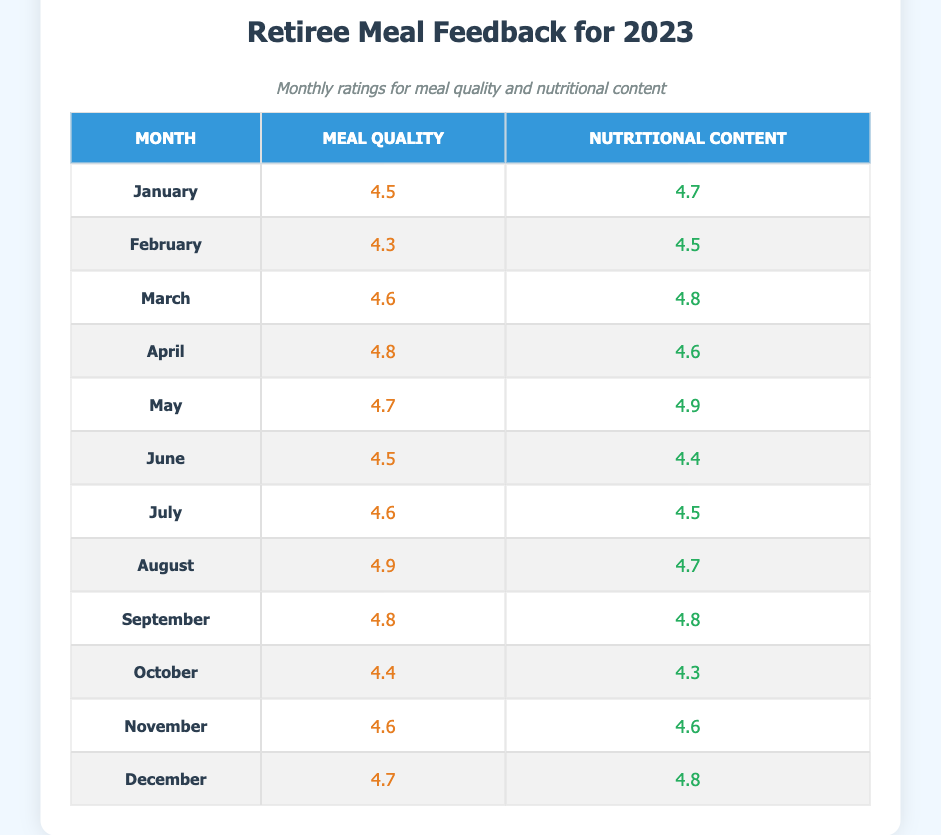What was the meal quality rating for March? The meal quality rating for March is listed directly in the table under the month of March. It shows a value of 4.6.
Answer: 4.6 Which month received the highest rating for nutritional content? The highest nutritional content rating can be found by reviewing each month's rating in the table. August has the highest rating at 4.9.
Answer: August What was the average meal quality rating for the first quarter (January, February, March)? To find the average for the first quarter, add the meal quality ratings for January (4.5), February (4.3), and March (4.6) which equals 13.4. Then divide by 3, resulting in an average of approximately 4.47.
Answer: 4.47 Is the meal quality rating for October higher or lower than the average meal quality rating for the entire year? First, we calculate the average meal quality rating for the year using the values from all months: (4.5+4.3+4.6+4.8+4.7+4.5+4.6+4.9+4.8+4.4+4.6+4.7) = 54.8 which divided by 12 gives about 4.57. October has a rating of 4.4, which is lower than 4.57.
Answer: Lower Which month saw a decrease in meal quality compared to the previous month? By examining the meal quality ratings month by month, June (4.5) is lower than May (4.7), indicating a decrease.
Answer: June What is the difference in nutritional content rating between the highest and lowest months? The highest month for nutritional content is May (4.9) and the lowest is October (4.3). The difference is 4.9 - 4.3 = 0.6.
Answer: 0.6 Did the meal quality rating in April improve compared to March? By comparing the ratings, April has a meal quality rating of 4.8 while March has 4.6. As 4.8 is greater than 4.6, it indicates an improvement in the meal quality rating.
Answer: Yes What is the total nutritional content rating for the last quarter (October, November, December)? The total for the last quarter is calculated by adding the nutritional content ratings for October (4.3), November (4.6), and December (4.8), resulting in 4.3 + 4.6 + 4.8 = 13.7.
Answer: 13.7 